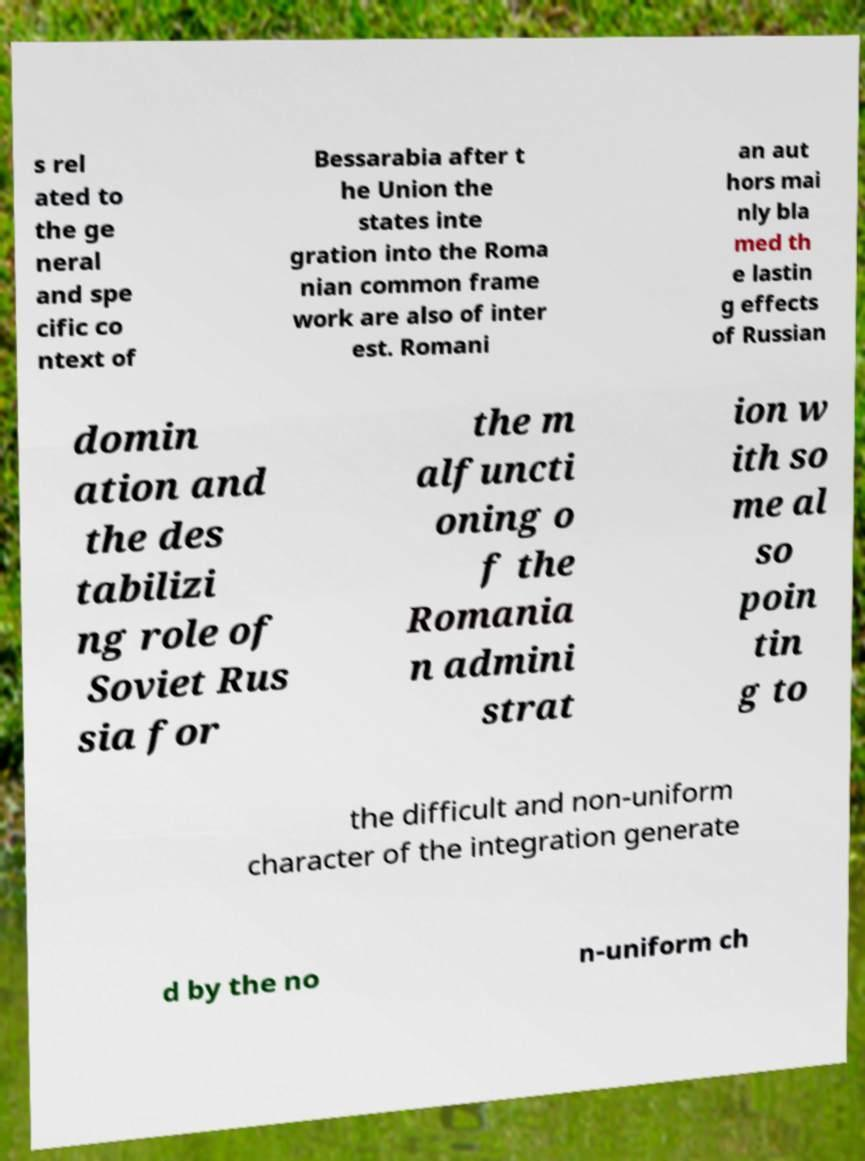There's text embedded in this image that I need extracted. Can you transcribe it verbatim? s rel ated to the ge neral and spe cific co ntext of Bessarabia after t he Union the states inte gration into the Roma nian common frame work are also of inter est. Romani an aut hors mai nly bla med th e lastin g effects of Russian domin ation and the des tabilizi ng role of Soviet Rus sia for the m alfuncti oning o f the Romania n admini strat ion w ith so me al so poin tin g to the difficult and non-uniform character of the integration generate d by the no n-uniform ch 